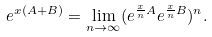<formula> <loc_0><loc_0><loc_500><loc_500>e ^ { x ( A + B ) } = \lim _ { n \to \infty } ( e ^ { { \frac { x } { n } } A } e ^ { { \frac { x } { n } } B } ) ^ { n } .</formula> 